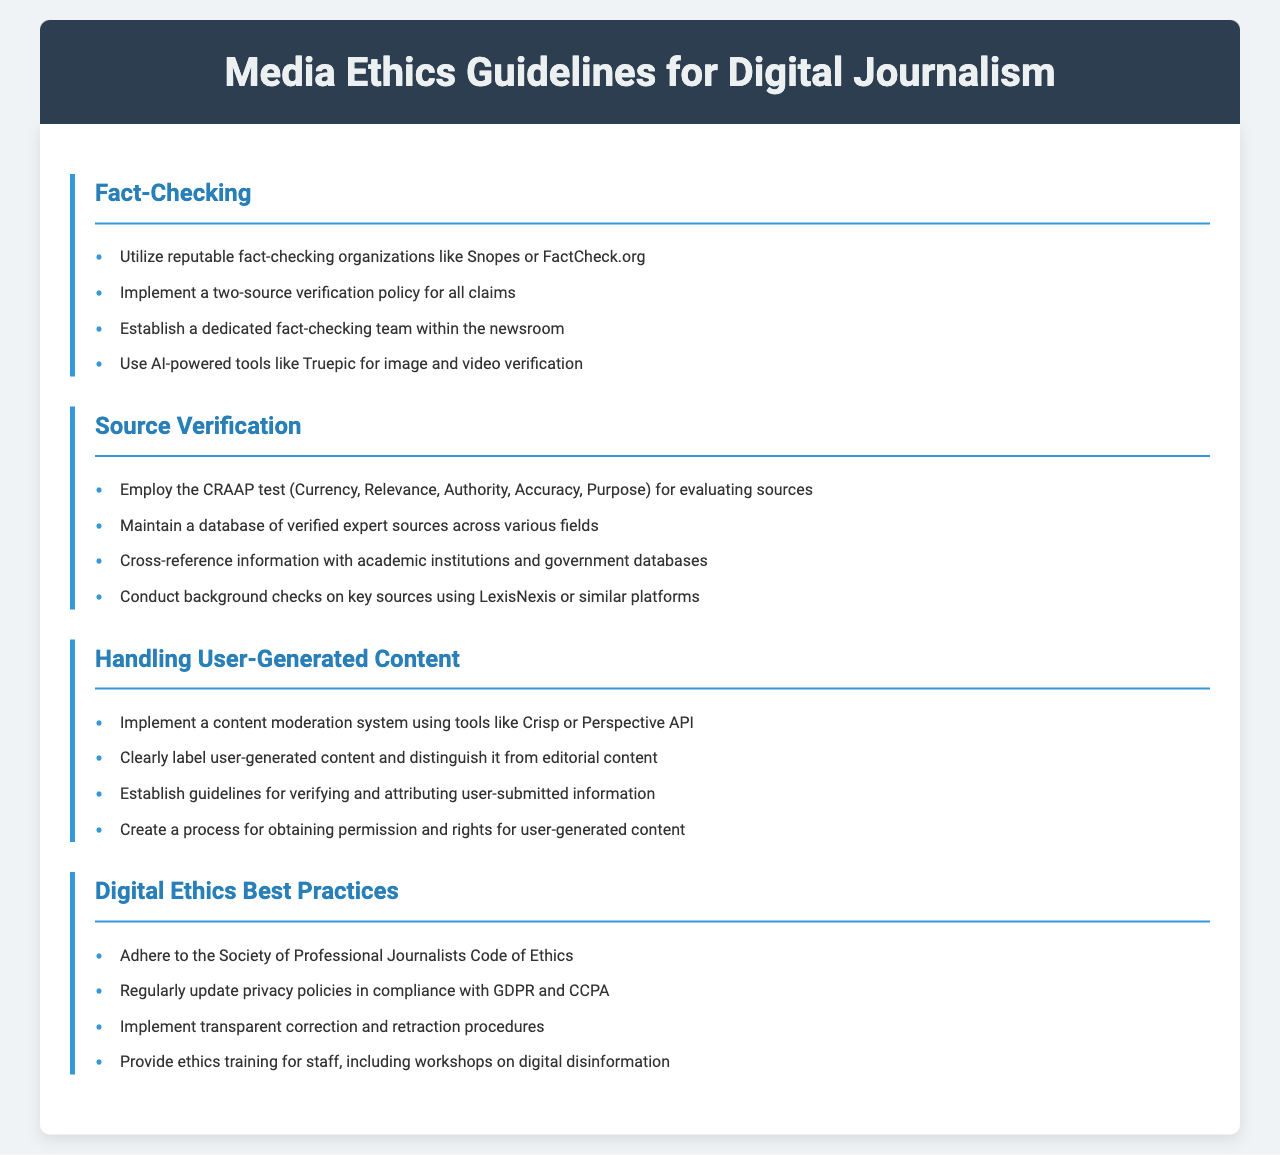What are some organizations recommended for fact-checking? The guidelines suggest utilizing reputable fact-checking organizations to ensure accuracy, with examples provided being Snopes and FactCheck.org.
Answer: Snopes, FactCheck.org What does the CRAAP test stand for? The document lists the CRAAP test as a method for evaluating sources, which stands for Currency, Relevance, Authority, Accuracy, and Purpose.
Answer: Currency, Relevance, Authority, Accuracy, Purpose How many sources should be verified before publishing a claim? The guidelines state that a two-source verification policy should be implemented for all claims made in digital journalism.
Answer: Two-source What tools are suggested for image and video verification? The document mentions the use of AI-powered tools for verification, specifically citing Truepic as an example.
Answer: Truepic What should be done with user-generated content according to the guidelines? The guidelines emphasize the importance of clearly labeling user-generated content to ensure it is distinguished from editorial content.
Answer: Clearly label What is a key goal of a dedicated fact-checking team? Establishing a dedicated team aims to enhance the accuracy of information and reduce the spread of misinformation in digital journalism.
Answer: Enhance accuracy What is one best practice mentioned for digital ethics? The document advises adherence to the Society of Professional Journalists Code of Ethics as one of the best practices for maintaining digital ethics.
Answer: Society of Professional Journalists Code of Ethics What process is suggested for user-generated content rights? The guidelines recommend creating a process for obtaining permission and rights for any user-generated content before it is published.
Answer: Obtain permission and rights What is the document's stance on privacy policies? It emphasizes the necessity to regularly update privacy policies in compliance with GDPR and CCPA to maintain ethical standards.
Answer: Regularly update privacy policies 